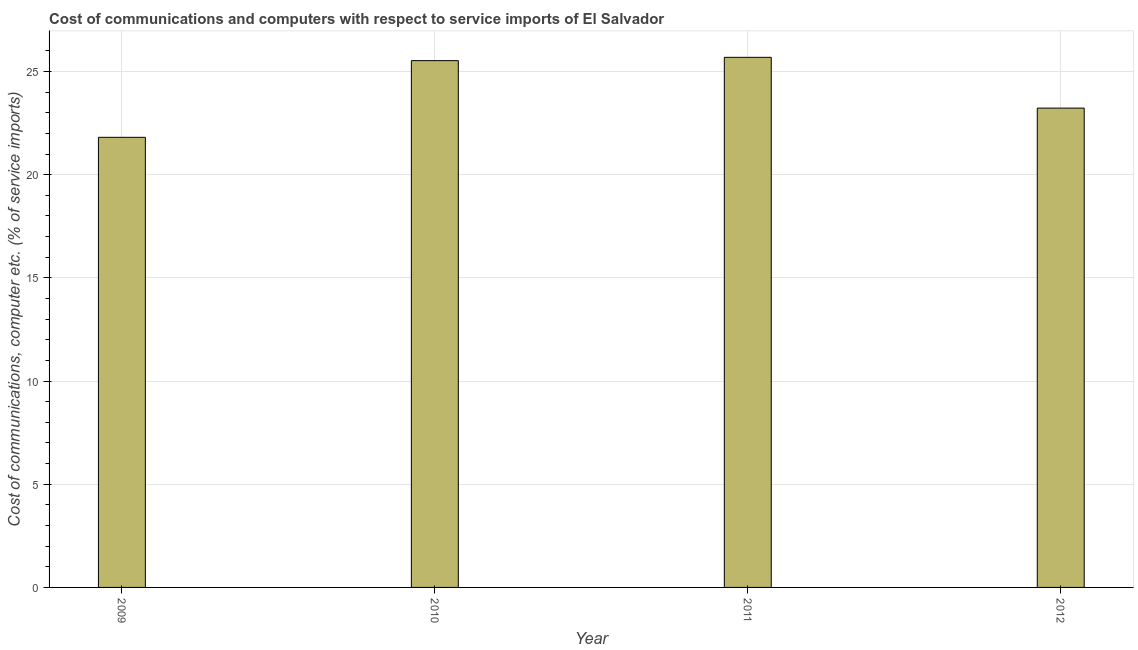What is the title of the graph?
Provide a short and direct response. Cost of communications and computers with respect to service imports of El Salvador. What is the label or title of the X-axis?
Provide a succinct answer. Year. What is the label or title of the Y-axis?
Your response must be concise. Cost of communications, computer etc. (% of service imports). What is the cost of communications and computer in 2009?
Offer a very short reply. 21.81. Across all years, what is the maximum cost of communications and computer?
Your response must be concise. 25.68. Across all years, what is the minimum cost of communications and computer?
Keep it short and to the point. 21.81. What is the sum of the cost of communications and computer?
Ensure brevity in your answer.  96.24. What is the difference between the cost of communications and computer in 2009 and 2012?
Provide a short and direct response. -1.42. What is the average cost of communications and computer per year?
Make the answer very short. 24.06. What is the median cost of communications and computer?
Your answer should be very brief. 24.37. In how many years, is the cost of communications and computer greater than 21 %?
Offer a very short reply. 4. Do a majority of the years between 2010 and 2012 (inclusive) have cost of communications and computer greater than 11 %?
Provide a short and direct response. Yes. Is the cost of communications and computer in 2010 less than that in 2011?
Offer a terse response. Yes. Is the difference between the cost of communications and computer in 2011 and 2012 greater than the difference between any two years?
Offer a very short reply. No. What is the difference between the highest and the second highest cost of communications and computer?
Offer a very short reply. 0.16. Is the sum of the cost of communications and computer in 2011 and 2012 greater than the maximum cost of communications and computer across all years?
Provide a succinct answer. Yes. What is the difference between the highest and the lowest cost of communications and computer?
Offer a very short reply. 3.88. Are all the bars in the graph horizontal?
Your answer should be very brief. No. Are the values on the major ticks of Y-axis written in scientific E-notation?
Provide a succinct answer. No. What is the Cost of communications, computer etc. (% of service imports) in 2009?
Your answer should be compact. 21.81. What is the Cost of communications, computer etc. (% of service imports) in 2010?
Ensure brevity in your answer.  25.52. What is the Cost of communications, computer etc. (% of service imports) of 2011?
Keep it short and to the point. 25.68. What is the Cost of communications, computer etc. (% of service imports) in 2012?
Offer a very short reply. 23.22. What is the difference between the Cost of communications, computer etc. (% of service imports) in 2009 and 2010?
Provide a short and direct response. -3.72. What is the difference between the Cost of communications, computer etc. (% of service imports) in 2009 and 2011?
Your answer should be very brief. -3.88. What is the difference between the Cost of communications, computer etc. (% of service imports) in 2009 and 2012?
Offer a very short reply. -1.42. What is the difference between the Cost of communications, computer etc. (% of service imports) in 2010 and 2011?
Offer a very short reply. -0.16. What is the difference between the Cost of communications, computer etc. (% of service imports) in 2010 and 2012?
Give a very brief answer. 2.3. What is the difference between the Cost of communications, computer etc. (% of service imports) in 2011 and 2012?
Ensure brevity in your answer.  2.46. What is the ratio of the Cost of communications, computer etc. (% of service imports) in 2009 to that in 2010?
Provide a short and direct response. 0.85. What is the ratio of the Cost of communications, computer etc. (% of service imports) in 2009 to that in 2011?
Your answer should be compact. 0.85. What is the ratio of the Cost of communications, computer etc. (% of service imports) in 2009 to that in 2012?
Offer a very short reply. 0.94. What is the ratio of the Cost of communications, computer etc. (% of service imports) in 2010 to that in 2012?
Offer a very short reply. 1.1. What is the ratio of the Cost of communications, computer etc. (% of service imports) in 2011 to that in 2012?
Your answer should be compact. 1.11. 